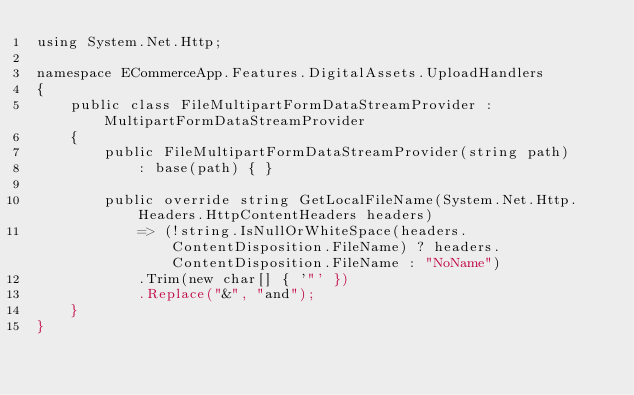Convert code to text. <code><loc_0><loc_0><loc_500><loc_500><_C#_>using System.Net.Http;

namespace ECommerceApp.Features.DigitalAssets.UploadHandlers
{
    public class FileMultipartFormDataStreamProvider : MultipartFormDataStreamProvider
    {
        public FileMultipartFormDataStreamProvider(string path)
            : base(path) { }

        public override string GetLocalFileName(System.Net.Http.Headers.HttpContentHeaders headers)
            => (!string.IsNullOrWhiteSpace(headers.ContentDisposition.FileName) ? headers.ContentDisposition.FileName : "NoName")
            .Trim(new char[] { '"' })
            .Replace("&", "and");        
    }
}
</code> 